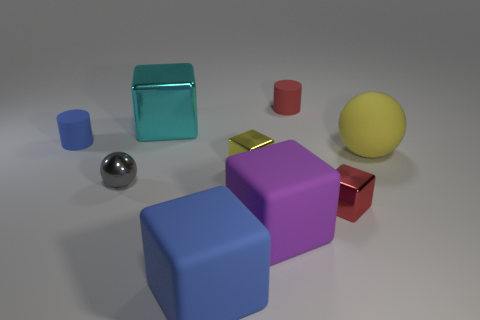Are there any metallic objects that have the same color as the matte ball?
Your response must be concise. Yes. The red object that is the same size as the red matte cylinder is what shape?
Give a very brief answer. Cube. There is a small yellow metal cube; are there any large rubber blocks to the left of it?
Offer a terse response. Yes. Is the material of the small red object behind the tiny yellow thing the same as the small cube on the right side of the yellow cube?
Offer a terse response. No. What number of blue cylinders are the same size as the purple block?
Give a very brief answer. 0. What is the shape of the small shiny object that is the same color as the rubber ball?
Give a very brief answer. Cube. There is a big object to the right of the purple object; what is it made of?
Make the answer very short. Rubber. How many cyan things have the same shape as the big blue rubber object?
Give a very brief answer. 1. There is a small thing that is made of the same material as the blue cylinder; what is its shape?
Offer a very short reply. Cylinder. There is a blue object that is on the right side of the small cylinder that is left of the blue rubber object that is in front of the yellow rubber ball; what shape is it?
Ensure brevity in your answer.  Cube. 